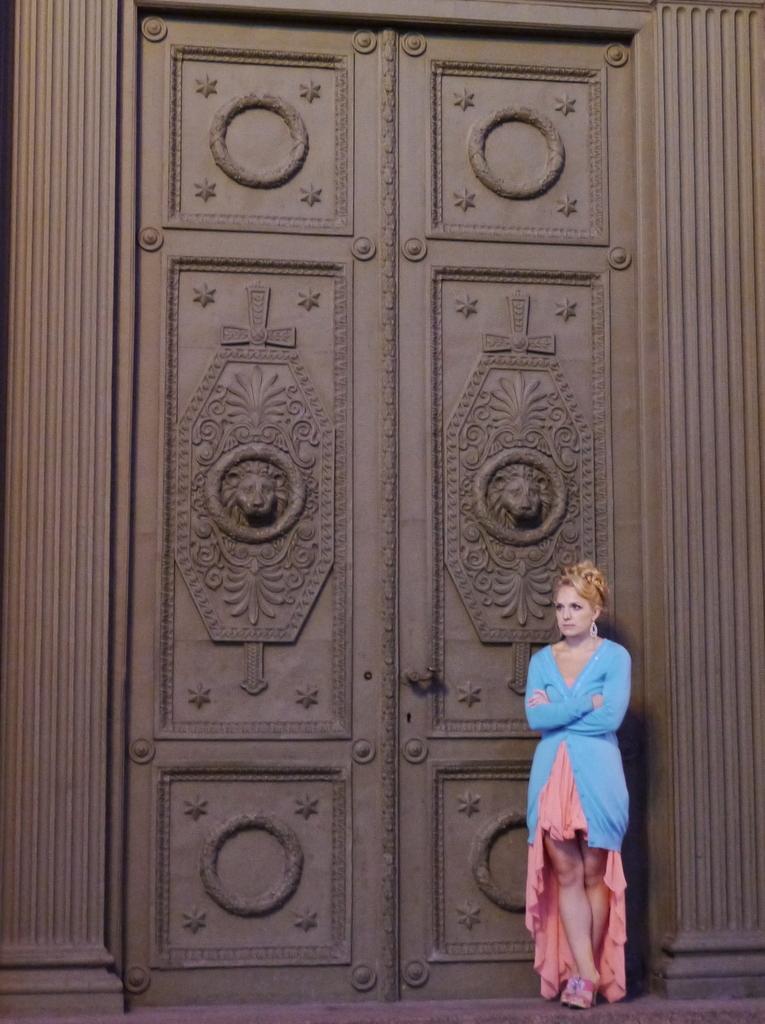Can you describe this image briefly? This image is taken outdoors. In the background there is a wall with a door with carvings. On the right side of the image a woman is standing on the floor. 